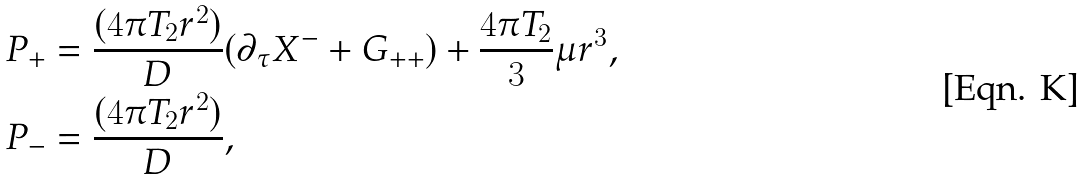<formula> <loc_0><loc_0><loc_500><loc_500>P _ { + } & = \frac { ( 4 \pi T _ { 2 } r ^ { 2 } ) } { D } ( \partial _ { \tau } X ^ { - } + G _ { + + } ) + \frac { 4 \pi T _ { 2 } } { 3 } \mu r ^ { 3 } , \\ P _ { - } & = \frac { ( 4 \pi T _ { 2 } r ^ { 2 } ) } { D } ,</formula> 